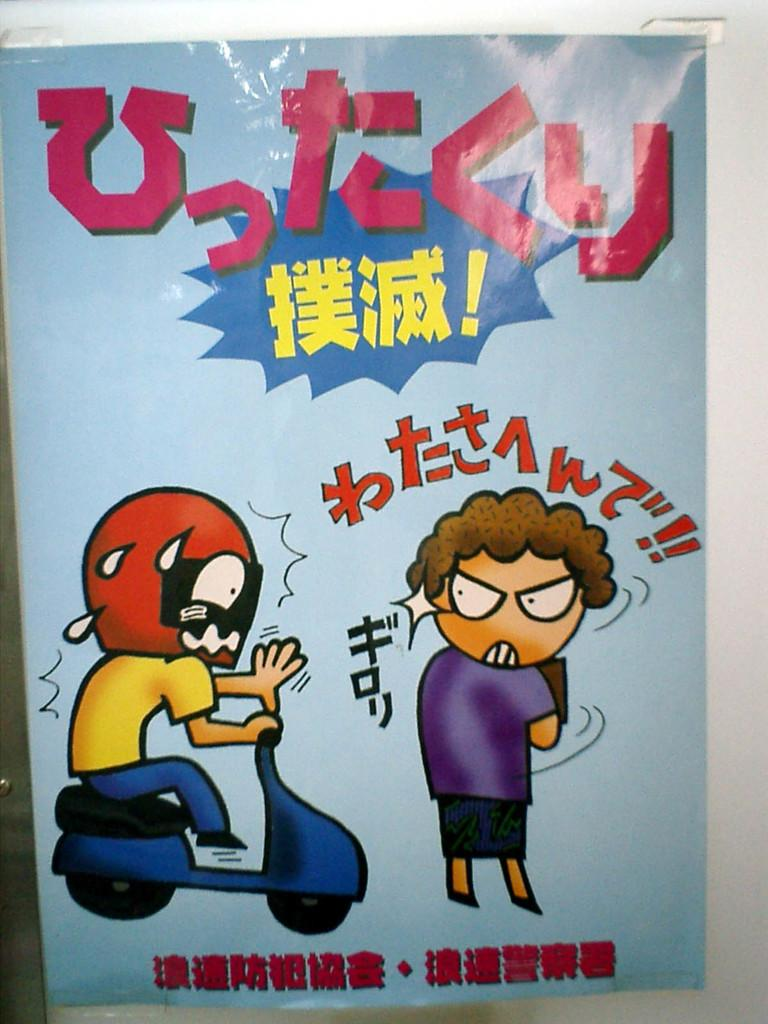What color is the paper on the wall in the image? The paper on the wall is blue. What is depicted on the paper? There are two people depicted on the paper. What is one of the people doing in the image on the paper? One person is sitting on a bike in the image on the paper. Is there any text or writing on the paper? Yes, there is writing on the paper. What type of pancake is being served on the wing of the airplane in the image? There is no pancake or airplane present in the image; it features a blue paper with two people depicted on it. Can you see a collar on the person sitting on the bike in the image on the paper? There is no mention of a collar in the description of the person sitting on the bike in the image on the paper. 